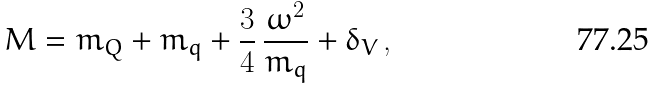<formula> <loc_0><loc_0><loc_500><loc_500>M = m _ { Q } + m _ { q } + \frac { 3 } { 4 } \, \frac { \omega ^ { 2 } } { m _ { q } } + \delta _ { V } \, ,</formula> 